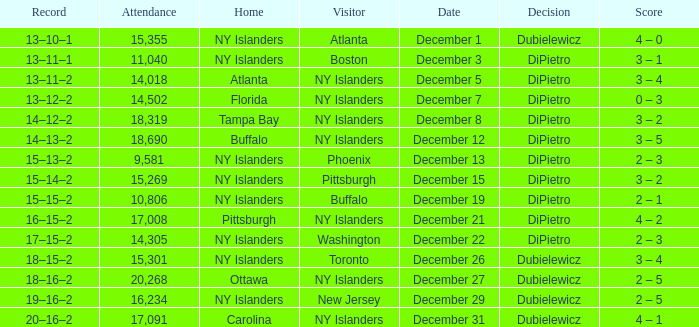Name the date for attendance more than 20,268 None. 